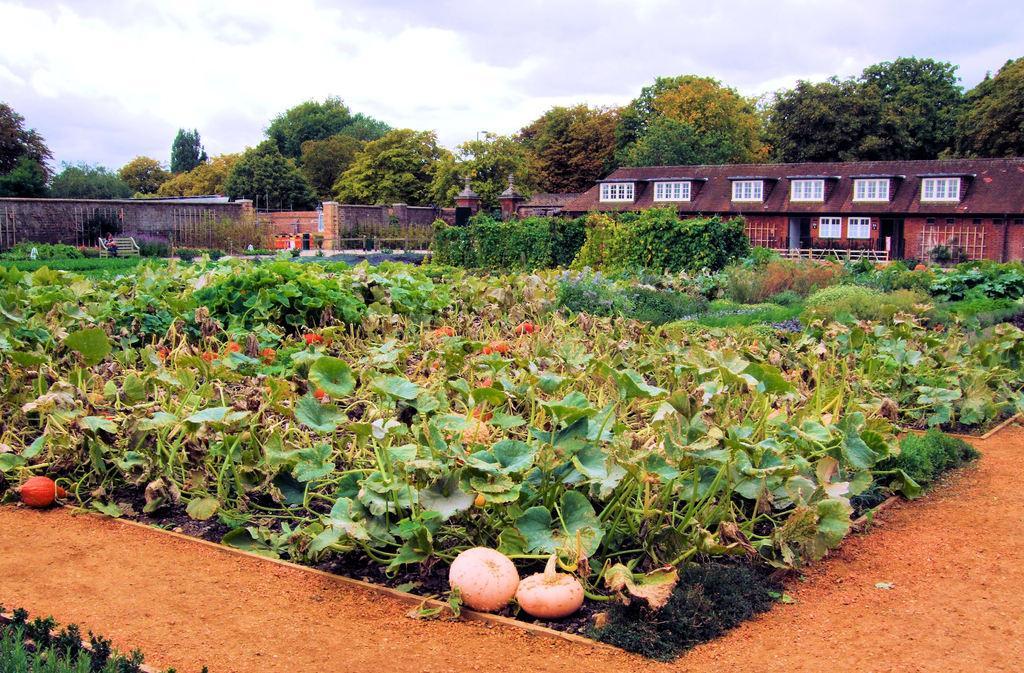Could you give a brief overview of what you see in this image? In this image there are creeper plants having flowers and vegetables. Behind there are plants on the land. Left side a person is sitting on the bench. Left side there is a wall. Right side there is a building. Background there are trees. Top of the image there is sky. Bottom of the image there is a path. 